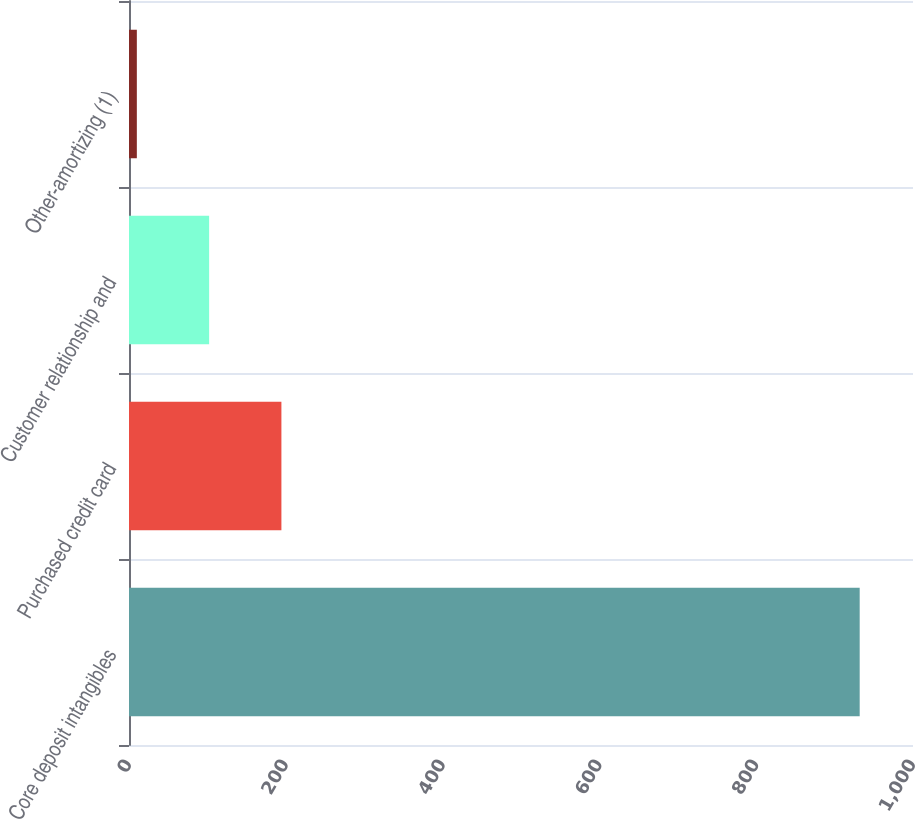<chart> <loc_0><loc_0><loc_500><loc_500><bar_chart><fcel>Core deposit intangibles<fcel>Purchased credit card<fcel>Customer relationship and<fcel>Other-amortizing (1)<nl><fcel>932<fcel>194.4<fcel>102.2<fcel>10<nl></chart> 